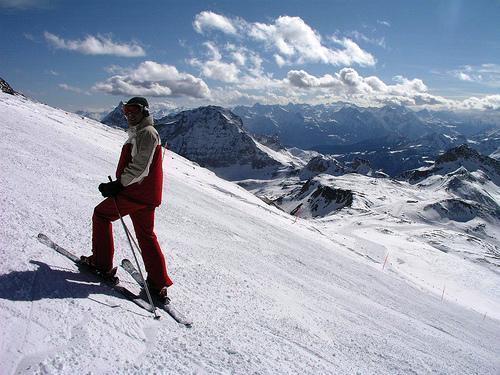How many skiers are there?
Give a very brief answer. 1. How many orange shorts do you see?
Give a very brief answer. 0. 